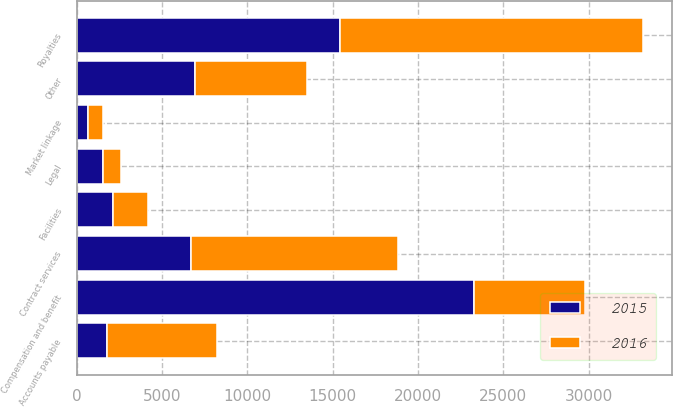Convert chart. <chart><loc_0><loc_0><loc_500><loc_500><stacked_bar_chart><ecel><fcel>Compensation and benefit<fcel>Royalties<fcel>Contract services<fcel>Accounts payable<fcel>Facilities<fcel>Legal<fcel>Market linkage<fcel>Other<nl><fcel>2016<fcel>6466<fcel>17807<fcel>12166<fcel>6466<fcel>2066<fcel>1052<fcel>917<fcel>6565<nl><fcel>2015<fcel>23304<fcel>15409<fcel>6684<fcel>1762<fcel>2099<fcel>1536<fcel>628<fcel>6904<nl></chart> 